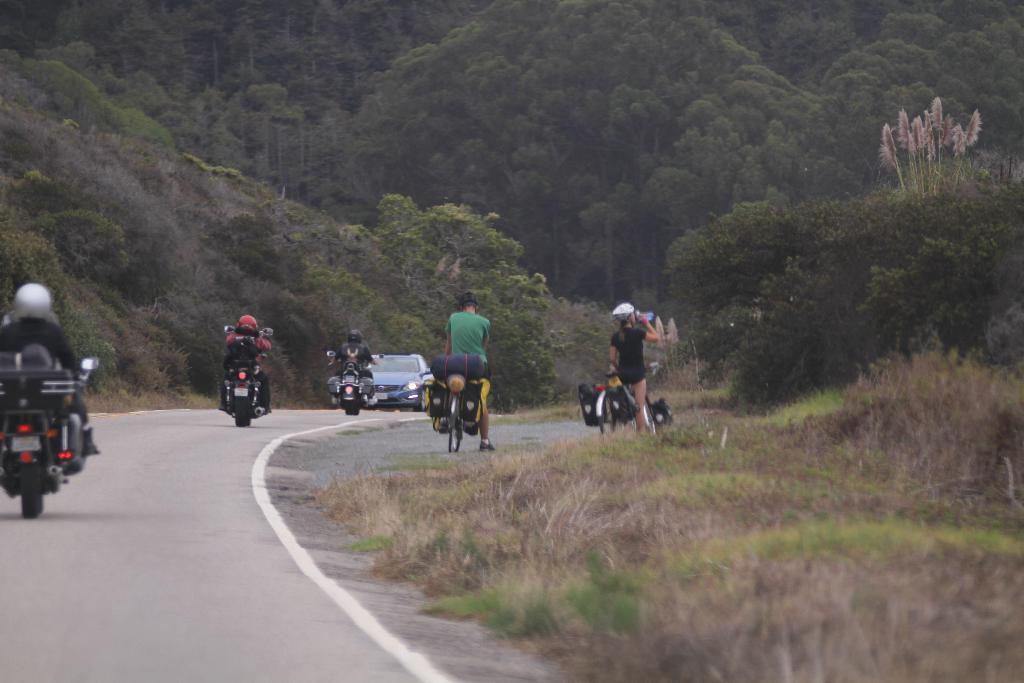In one or two sentences, can you explain what this image depicts? In this image we can see people are riding bicycles and bike on the road. In the background, we can see the car. We can see the dry grass in the right bottom of the image. At the top of the image, we can see the trees. 